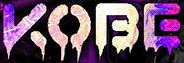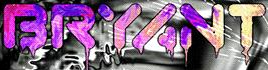Identify the words shown in these images in order, separated by a semicolon. KOBE; BRYANT 